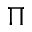<formula> <loc_0><loc_0><loc_500><loc_500>\Pi</formula> 